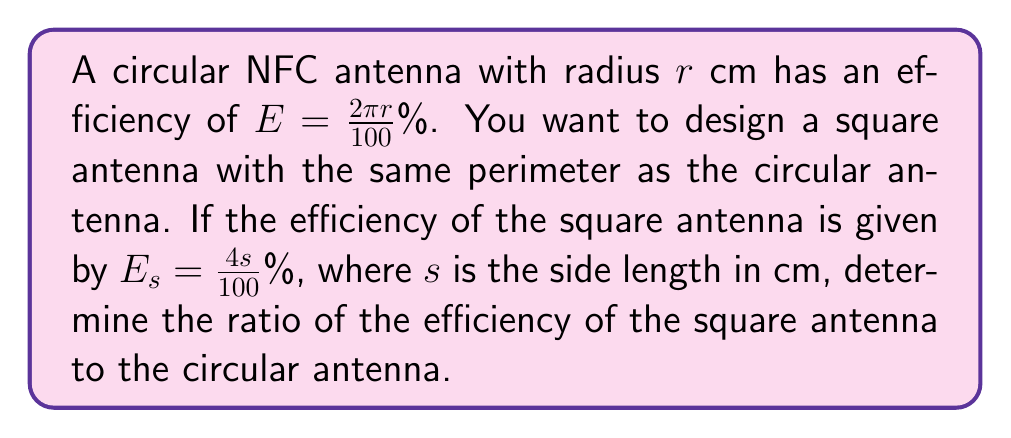Provide a solution to this math problem. 1. First, let's express the perimeter of the circular antenna:
   Perimeter of circle = $2\pi r$ cm

2. For the square antenna to have the same perimeter:
   $4s = 2\pi r$
   $s = \frac{\pi r}{2}$ cm

3. Now, let's calculate the efficiency of the square antenna:
   $E_s = \frac{4s}{100}$%
   $E_s = \frac{4(\frac{\pi r}{2})}{100}$%
   $E_s = \frac{2\pi r}{100}$%

4. Recall that the efficiency of the circular antenna is:
   $E = \frac{2\pi r}{100}$%

5. To find the ratio of efficiencies, we divide $E_s$ by $E$:
   $\frac{E_s}{E} = \frac{\frac{2\pi r}{100}}{\frac{2\pi r}{100}} = 1$

This means the efficiencies are equal, and their ratio is 1:1.
Answer: 1:1 